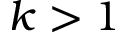<formula> <loc_0><loc_0><loc_500><loc_500>k > 1</formula> 